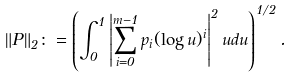Convert formula to latex. <formula><loc_0><loc_0><loc_500><loc_500>\| P \| _ { 2 } \colon = \left ( \int _ { 0 } ^ { 1 } \left | \sum _ { i = 0 } ^ { m - 1 } p _ { i } ( \log u ) ^ { i } \right | ^ { 2 } u d u \right ) ^ { 1 / 2 } .</formula> 